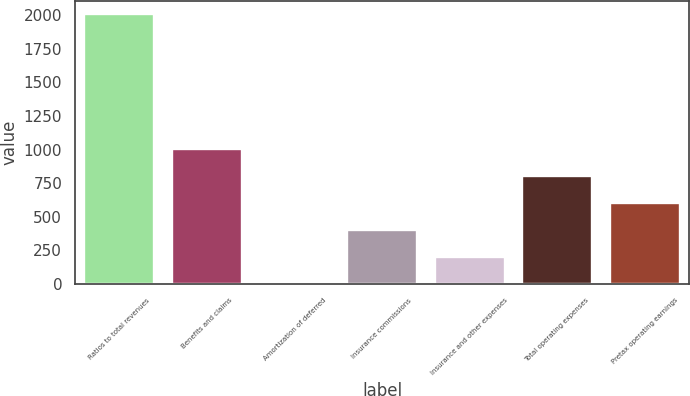<chart> <loc_0><loc_0><loc_500><loc_500><bar_chart><fcel>Ratios to total revenues<fcel>Benefits and claims<fcel>Amortization of deferred<fcel>Insurance commissions<fcel>Insurance and other expenses<fcel>Total operating expenses<fcel>Pretax operating earnings<nl><fcel>2006<fcel>1004.35<fcel>2.7<fcel>403.36<fcel>203.03<fcel>804.02<fcel>603.69<nl></chart> 